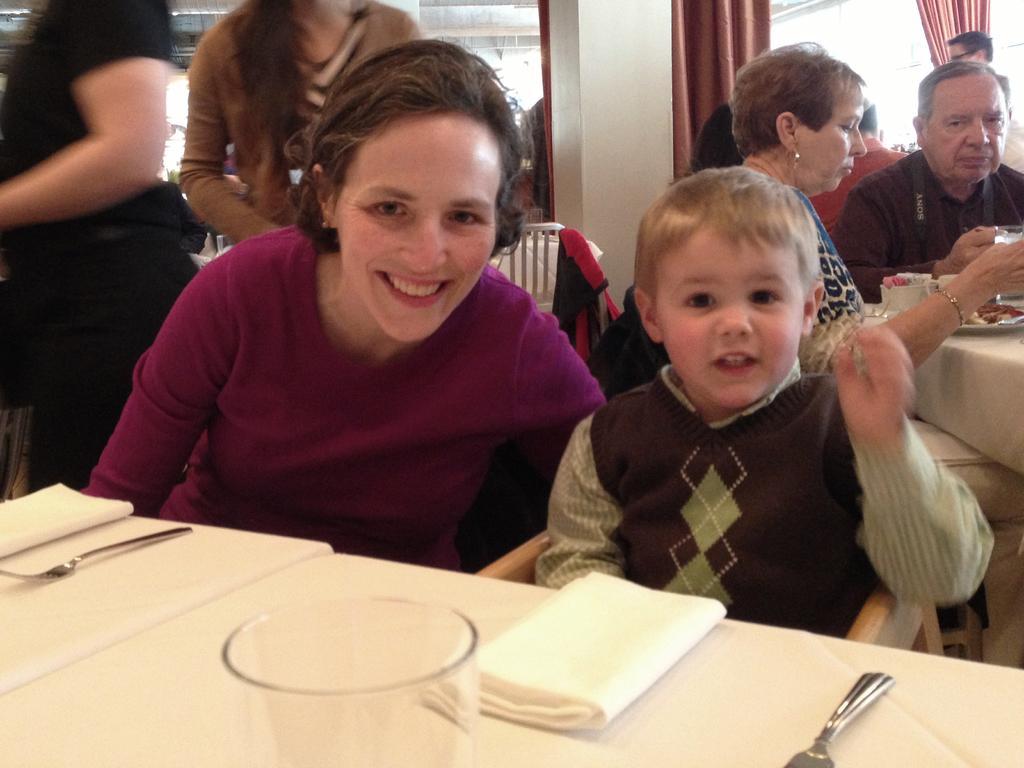In one or two sentences, can you explain what this image depicts? In this image there is a boy sitting on the chair. Before him there is a table having a glass, napkins and forks. Beside him there is a woman. Right side there are people. Right side there is a table having a plate and few objects. Left side there are people standing. Right top there are curtains. 